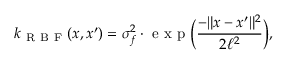Convert formula to latex. <formula><loc_0><loc_0><loc_500><loc_500>k _ { R B F } ( x , x ^ { \prime } ) = \sigma _ { f } ^ { 2 } \cdot e x p \left ( \frac { - \| x - x ^ { \prime } \| ^ { 2 } } { 2 \ell ^ { 2 } } \right ) ,</formula> 